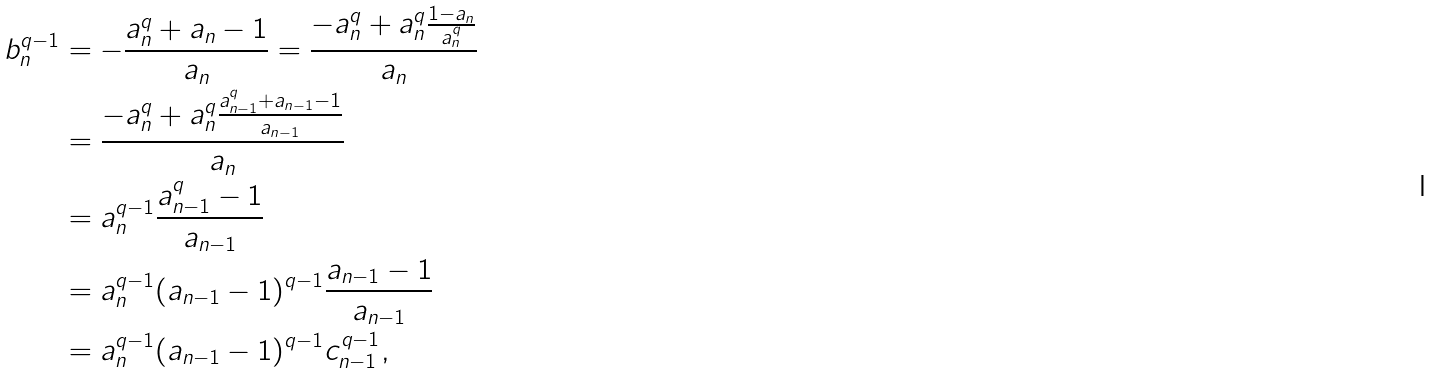<formula> <loc_0><loc_0><loc_500><loc_500>b _ { n } ^ { q - 1 } & = - \frac { a _ { n } ^ { q } + a _ { n } - 1 } { a _ { n } } = \frac { - a _ { n } ^ { q } + a _ { n } ^ { q } \frac { 1 - a _ { n } } { a _ { n } ^ { q } } } { a _ { n } } \\ & = \frac { - a _ { n } ^ { q } + a _ { n } ^ { q } \frac { a _ { n - 1 } ^ { q } + a _ { n - 1 } - 1 } { a _ { n - 1 } } } { a _ { n } } \\ & = a _ { n } ^ { q - 1 } \frac { a _ { n - 1 } ^ { q } - 1 } { a _ { n - 1 } } \\ & = a _ { n } ^ { q - 1 } ( a _ { n - 1 } - 1 ) ^ { q - 1 } \frac { a _ { n - 1 } - 1 } { a _ { n - 1 } } \\ & = a _ { n } ^ { q - 1 } ( a _ { n - 1 } - 1 ) ^ { q - 1 } c _ { n - 1 } ^ { q - 1 } ,</formula> 